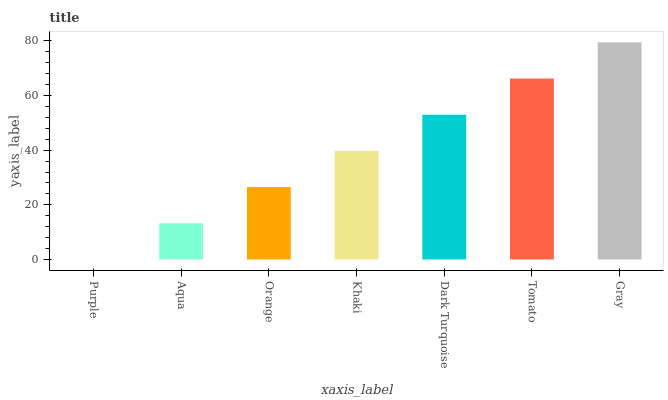Is Purple the minimum?
Answer yes or no. Yes. Is Gray the maximum?
Answer yes or no. Yes. Is Aqua the minimum?
Answer yes or no. No. Is Aqua the maximum?
Answer yes or no. No. Is Aqua greater than Purple?
Answer yes or no. Yes. Is Purple less than Aqua?
Answer yes or no. Yes. Is Purple greater than Aqua?
Answer yes or no. No. Is Aqua less than Purple?
Answer yes or no. No. Is Khaki the high median?
Answer yes or no. Yes. Is Khaki the low median?
Answer yes or no. Yes. Is Orange the high median?
Answer yes or no. No. Is Orange the low median?
Answer yes or no. No. 